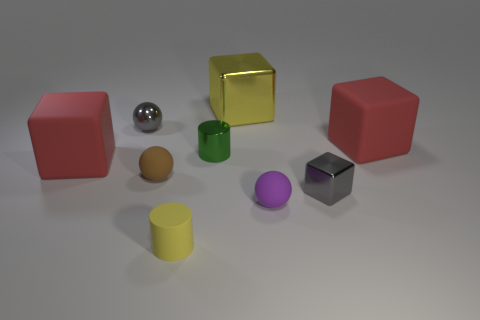How many balls are the same color as the tiny block?
Make the answer very short. 1. There is a tiny cylinder that is the same material as the large yellow cube; what color is it?
Your answer should be compact. Green. How many shiny objects are either cyan things or large yellow things?
Ensure brevity in your answer.  1. What shape is the green object that is the same size as the yellow cylinder?
Keep it short and to the point. Cylinder. What number of things are either red blocks on the right side of the purple thing or gray metal objects that are left of the purple object?
Offer a very short reply. 2. There is a yellow thing that is the same size as the green metallic thing; what material is it?
Your response must be concise. Rubber. How many other objects are there of the same material as the gray sphere?
Provide a succinct answer. 3. Is the number of green metallic cylinders on the right side of the yellow shiny thing the same as the number of tiny purple objects left of the brown matte ball?
Make the answer very short. Yes. What number of brown objects are tiny rubber balls or tiny cubes?
Ensure brevity in your answer.  1. Is the color of the matte cylinder the same as the cube that is in front of the small brown rubber sphere?
Offer a very short reply. No. 